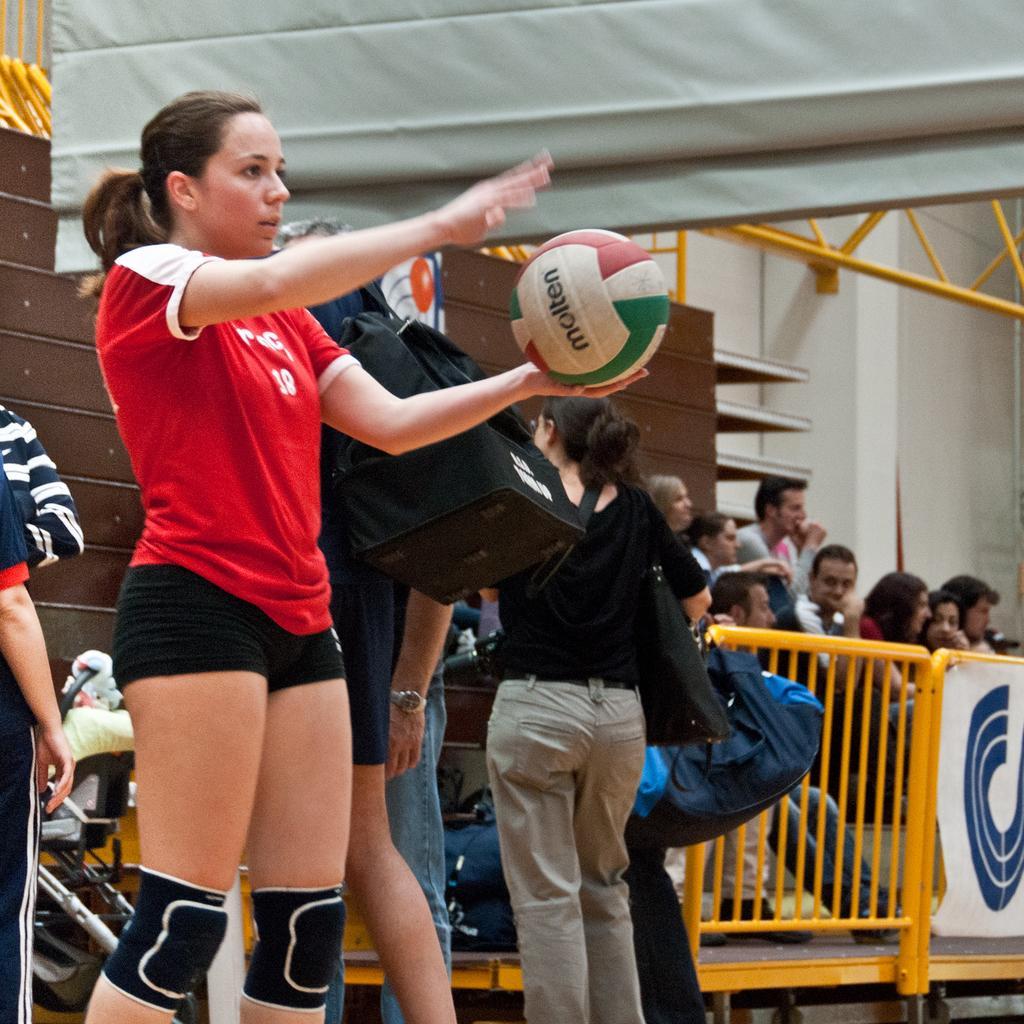How would you summarize this image in a sentence or two? In the picture we can see a woman holding a ball, in the background we can see many people standing near the railing. 